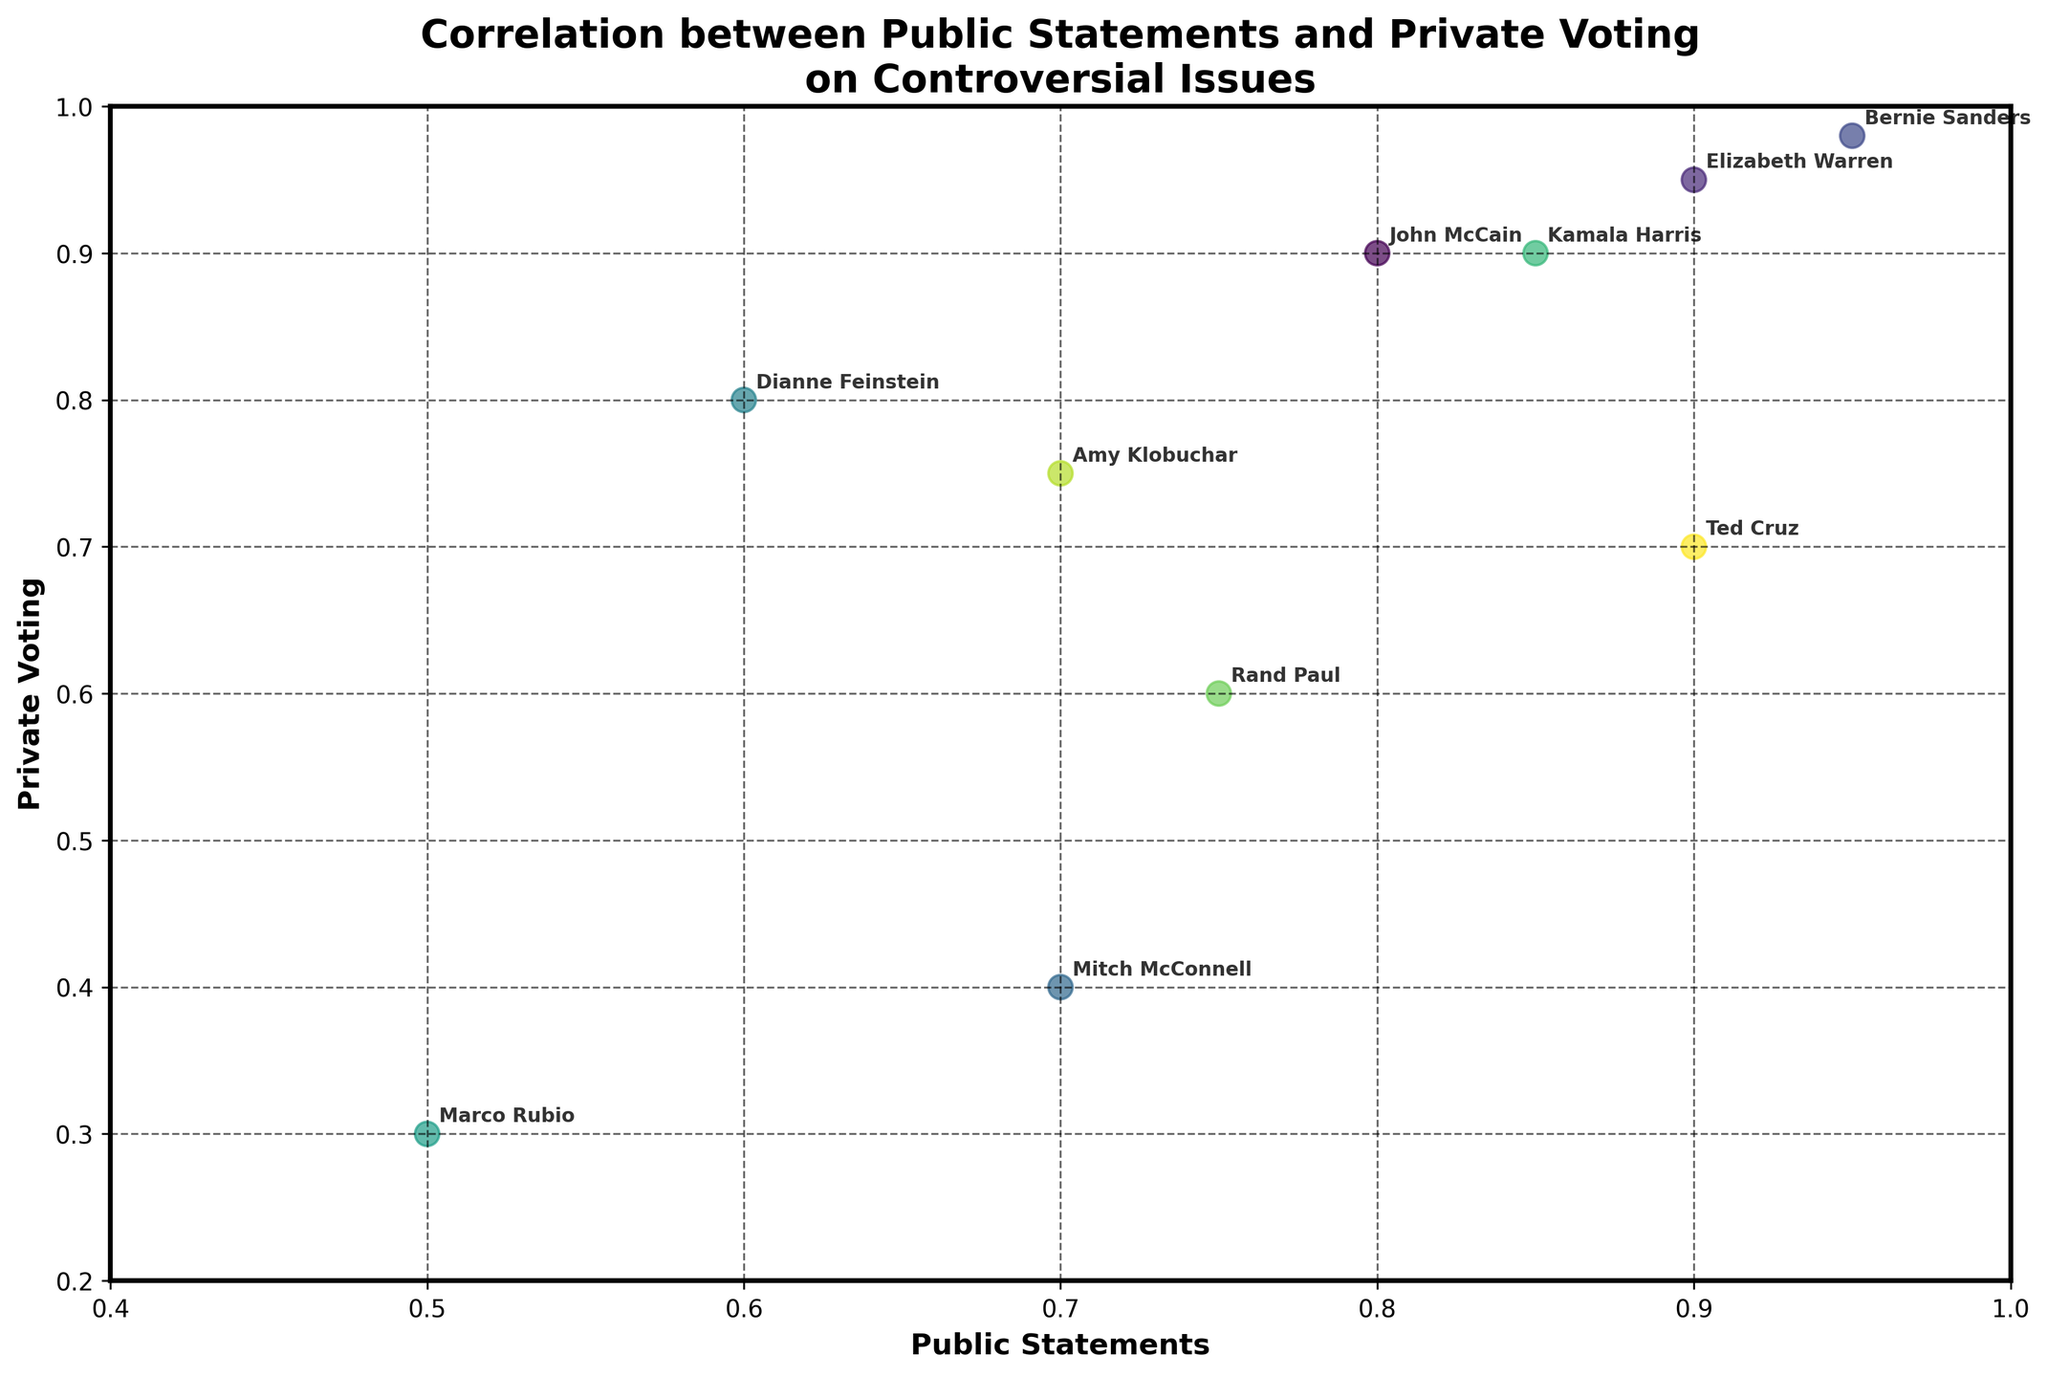Which senator has the highest public statement score? The highest public statement score among the senators can be found by identifying the point farthest to the right on the x-axis, as the x-axis represents public statements. Bernie Sanders has the highest score at 0.95.
Answer: Bernie Sanders Which senator has the greatest discrepancy between public statements and private voting? The greatest discrepancy can be identified by finding the longest vertical distance between a point and the line y=x (where public statements equal private voting). Mitch McConnell has the greatest discrepancy between his public statements (0.7) and private voting (0.4), resulting in a difference of 0.3.
Answer: Mitch McConnell What is the average private voting score of senators who have a public statement score above 0.8? To find the average private voting score of senators with a public statement score above 0.8, first identify those senators: John McCain, Elizabeth Warren, Bernie Sanders, Kamala Harris, and Ted Cruz. Their private voting scores are 0.9, 0.95, 0.98, 0.9, and 0.7, respectively. The average is calculated as (0.9+0.95+0.98+0.9+0.7) / 5 = 4.43 / 5 = 0.886.
Answer: 0.886 Which issue corresponds to Amy Klobuchar? To find the issue corresponding to Amy Klobuchar, locate her data point and identify the matching issue. Amy Klobuchar is found at the coordinates (0.7, 0.75), corresponding to Infrastructure Spending in the data table.
Answer: Infrastructure Spending Which two senators have the closest alignment between their public statements and private voting scores? The closest alignment is found by identifying the points closest to the line y=x. The senators with these points are Bernie Sanders (0.95, 0.98) and Elizabeth Warren (0.9, 0.95). Since both are very close, we calculate the differences: Bernie Sanders has a difference of 0.03 (0.98-0.95) and Elizabeth Warren has a difference of 0.05 (0.95-0.9). Thus, Bernie Sanders has the closest alignment.
Answer: Bernie Sanders What’s the median public statement score of all the senators? To find the median public statement score, first list all public statement scores: [0.5, 0.6, 0.7, 0.7, 0.75, 0.8, 0.85, 0.9, 0.9, 0.95]. The median is the middle value in a sorted list. With 10 values, the median is the average of the 5th and 6th values: (0.75+0.8)/2 = 0.775.
Answer: 0.775 Between John McCain and Ted Cruz, who has a higher private voting score? To see who has a higher private voting score, compare the y-axis values of John McCain and Ted Cruz. John McCain's private voting score is 0.9 and Ted Cruz's is 0.7, so John McCain has the higher score.
Answer: John McCain Which senator is most aligned with the issue of Financial Regulation? First, note that the issue of Financial Regulation corresponds to Elizabeth Warren. Then check her coordinates (0.9, 0.95) to confirm.
Answer: Elizabeth Warren 